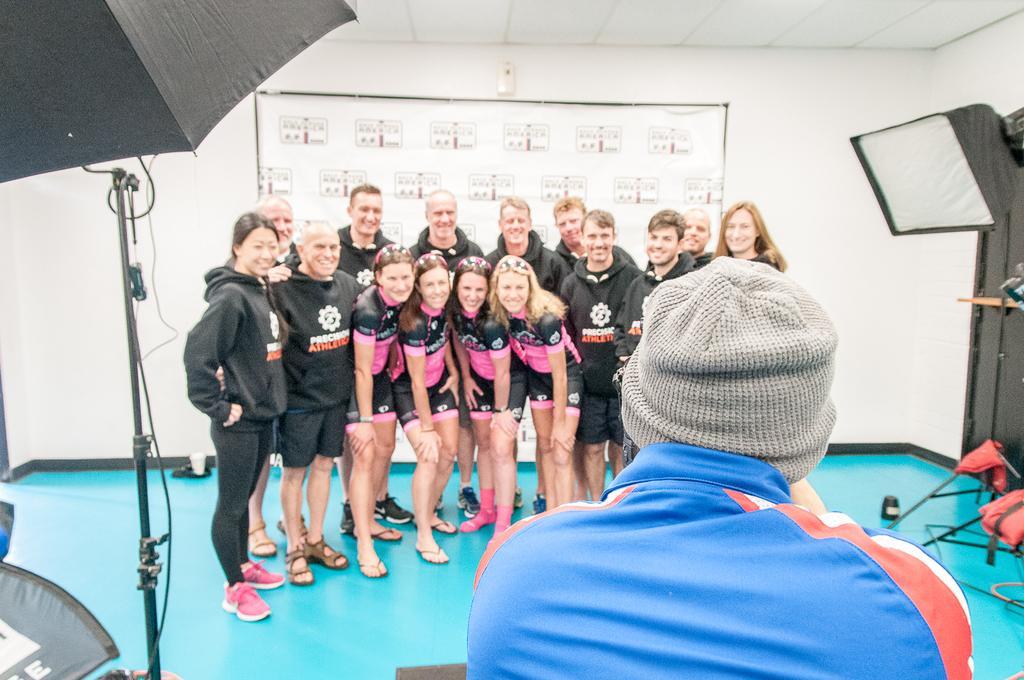Can you describe this image briefly? In this image we can see a few people standing on the stage, in front of them, we can see a person holding a camera and taking a photograph, there are lights and a banner, in the background, we can see the wall. 